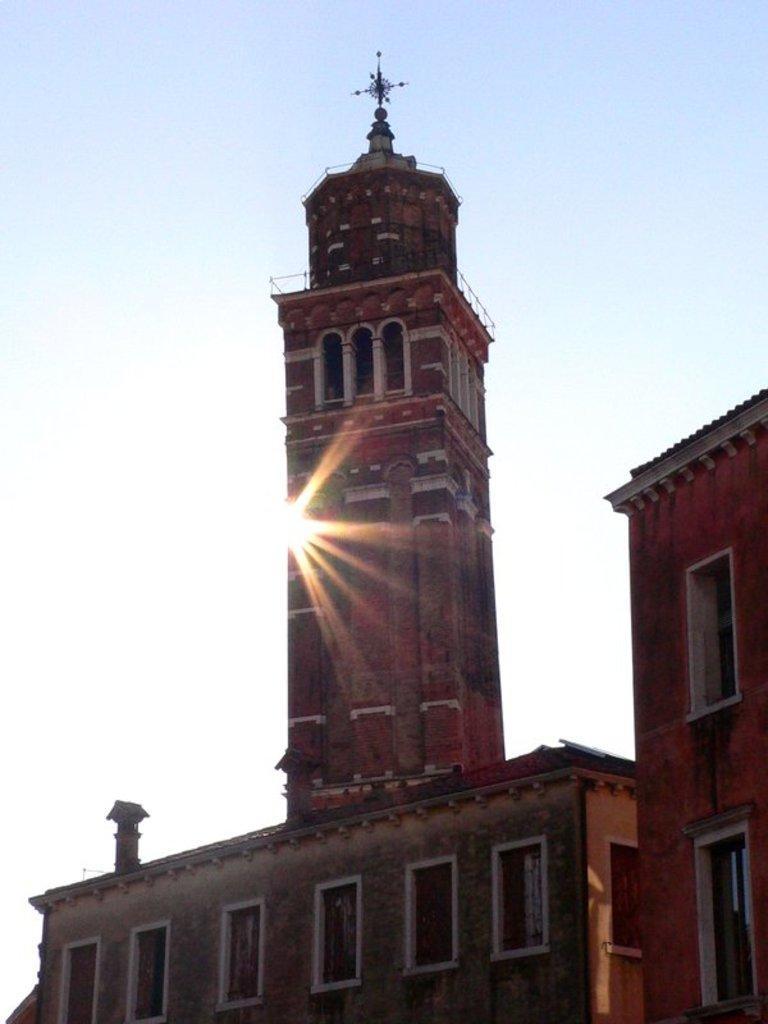Can you describe this image briefly? In this image there are buildings. In the background of the image there is a sun and sky. 